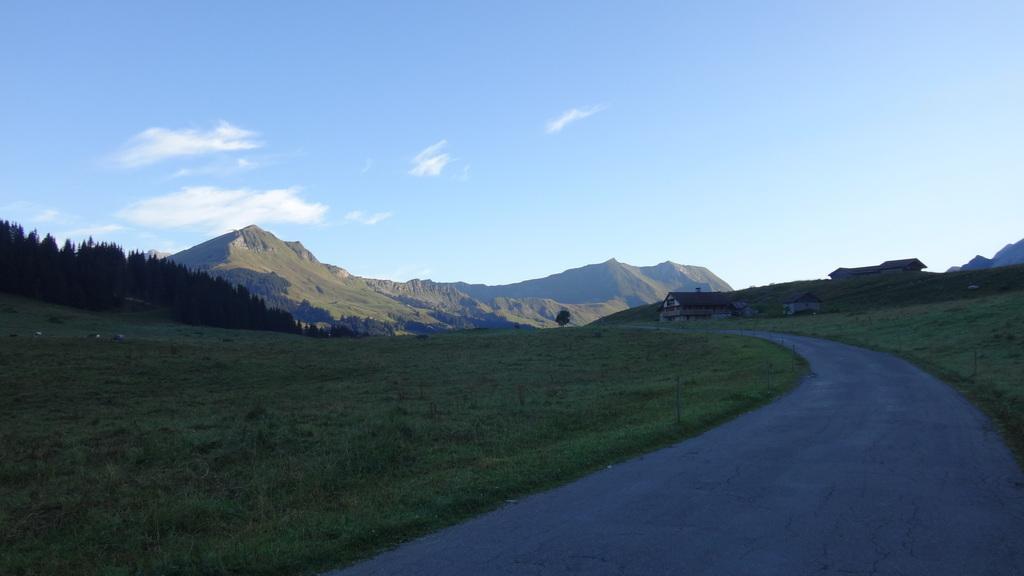Please provide a concise description of this image. On the right we can see path and to the either side of the path we can see grass on the ground. In the background we can see houses on the right and trees ,mountains and clouds in the sky. 